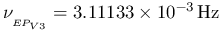Convert formula to latex. <formula><loc_0><loc_0><loc_500><loc_500>\nu _ { _ { E P _ { V 3 } } } = 3 . 1 1 1 3 3 \times 1 0 ^ { - 3 } \, { H z }</formula> 